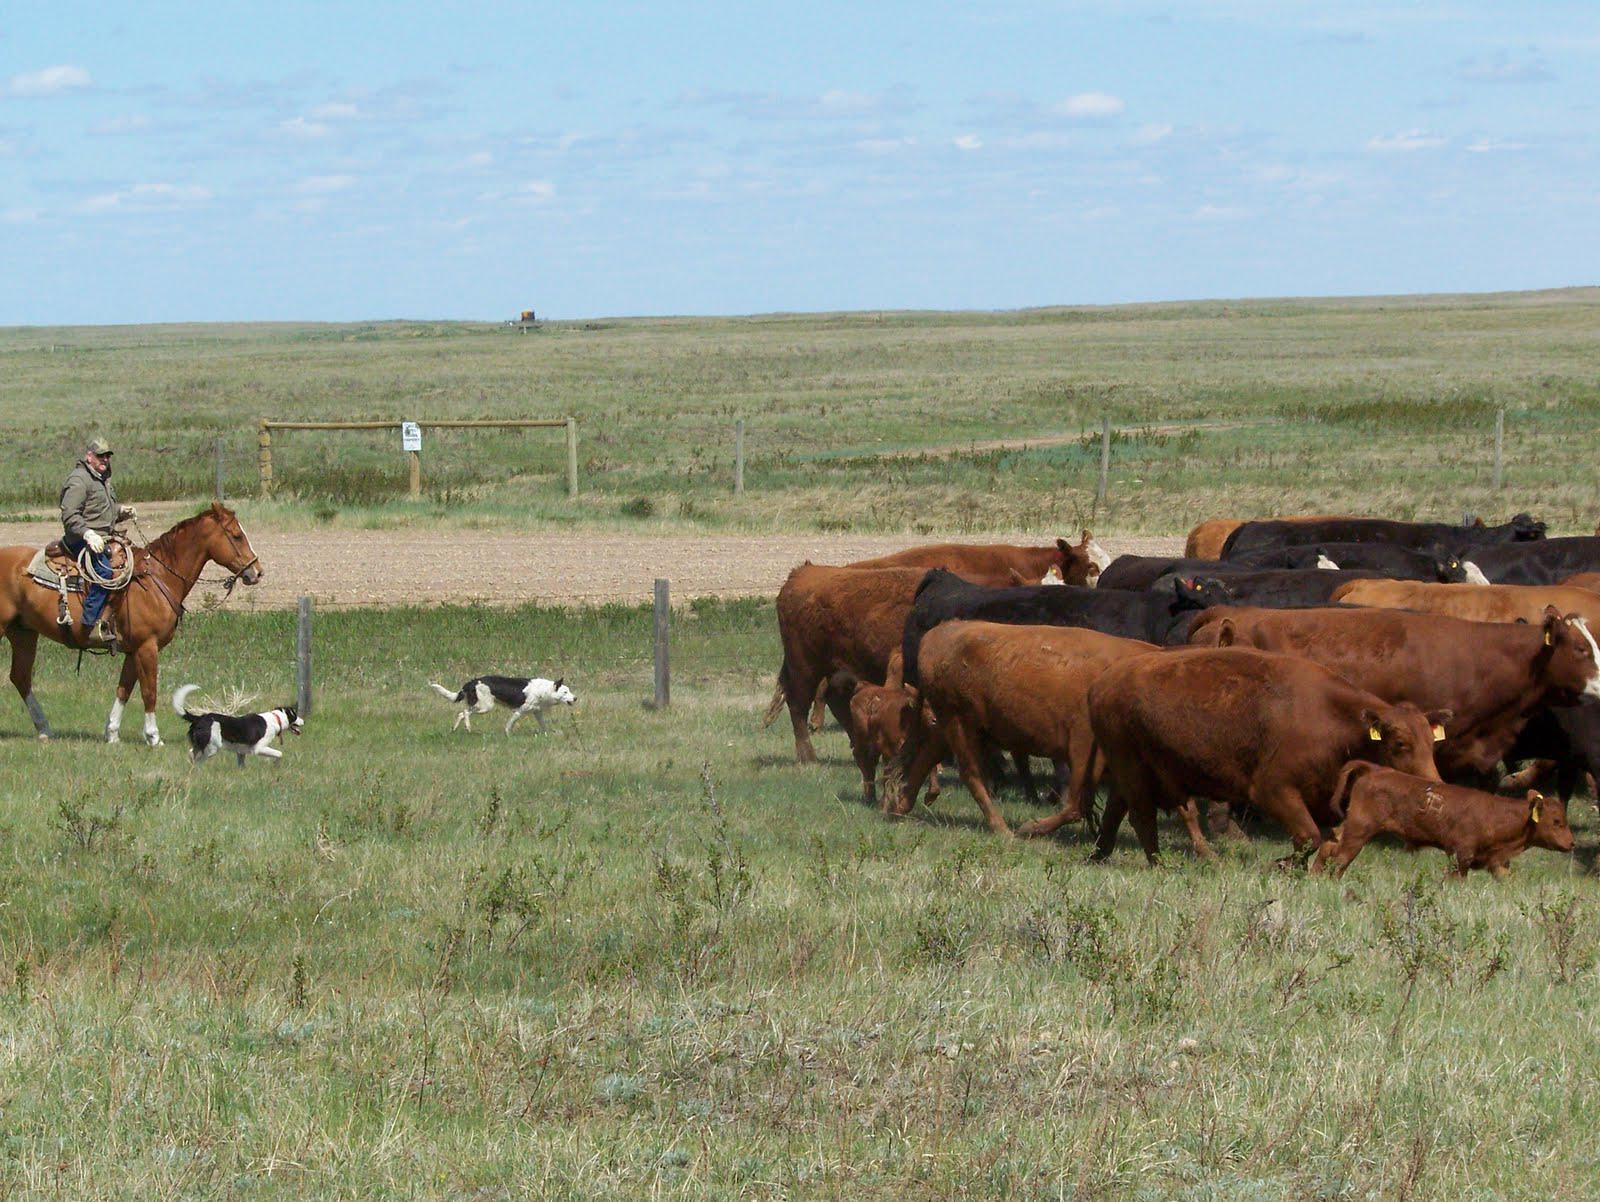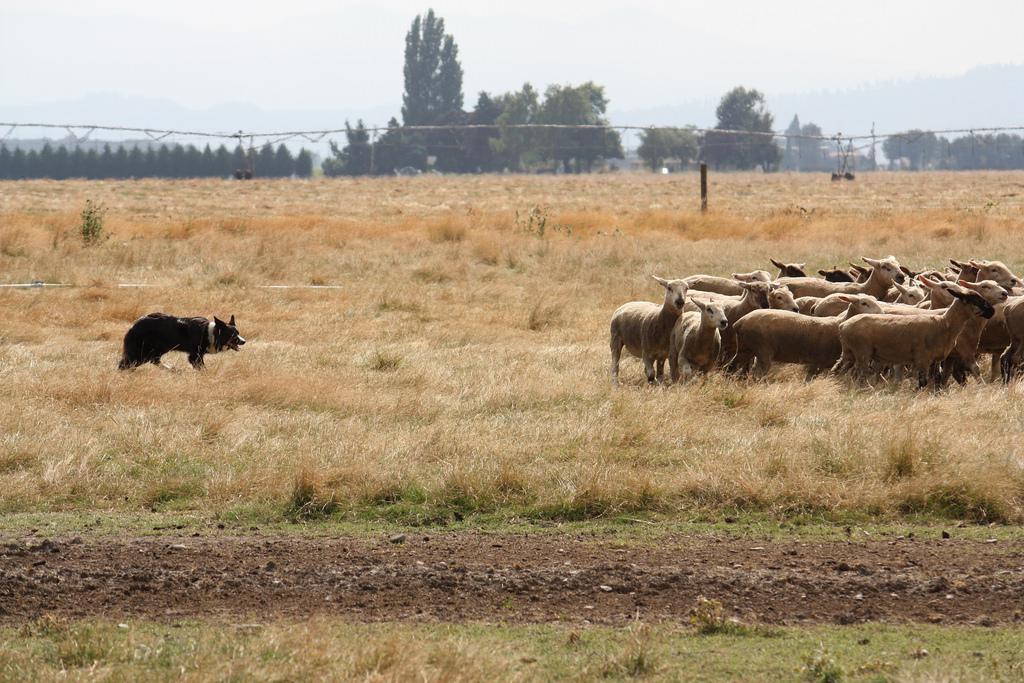The first image is the image on the left, the second image is the image on the right. For the images displayed, is the sentence "A dog is herding sheep." factually correct? Answer yes or no. Yes. The first image is the image on the left, the second image is the image on the right. Assess this claim about the two images: "In the right image, there's a single dog herding some sheep on its own.". Correct or not? Answer yes or no. Yes. 